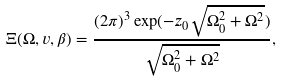Convert formula to latex. <formula><loc_0><loc_0><loc_500><loc_500>\Xi ( \Omega , v , \beta ) = \frac { ( 2 \pi ) ^ { 3 } \exp ( - z _ { 0 } \sqrt { \Omega ^ { 2 } _ { 0 } + \Omega ^ { 2 } } ) } { \sqrt { \Omega ^ { 2 } _ { 0 } + \Omega ^ { 2 } } } ,</formula> 